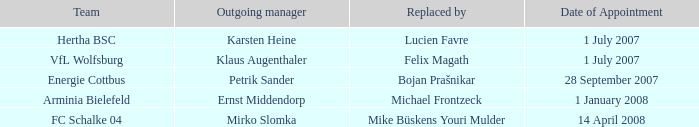Give me the full table as a dictionary. {'header': ['Team', 'Outgoing manager', 'Replaced by', 'Date of Appointment'], 'rows': [['Hertha BSC', 'Karsten Heine', 'Lucien Favre', '1 July 2007'], ['VfL Wolfsburg', 'Klaus Augenthaler', 'Felix Magath', '1 July 2007'], ['Energie Cottbus', 'Petrik Sander', 'Bojan Prašnikar', '28 September 2007'], ['Arminia Bielefeld', 'Ernst Middendorp', 'Michael Frontzeck', '1 January 2008'], ['FC Schalke 04', 'Mirko Slomka', 'Mike Büskens Youri Mulder', '14 April 2008']]} When was the departure date when a manager was replaced by Bojan Prašnikar? 23 September 2007. 